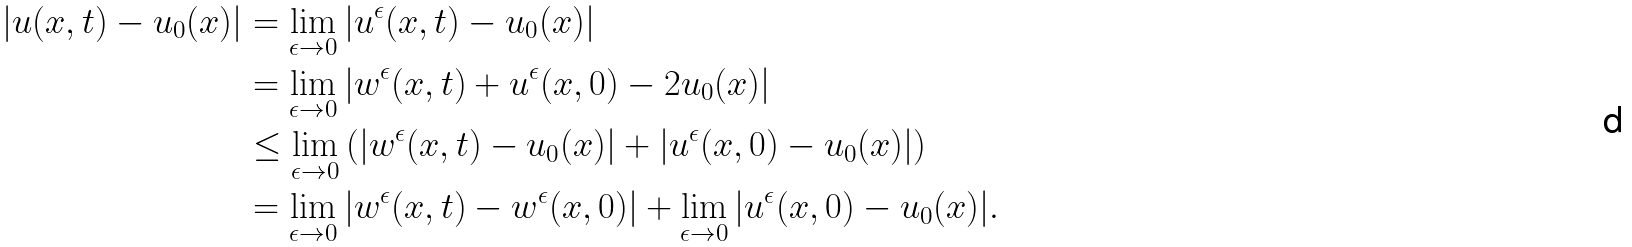Convert formula to latex. <formula><loc_0><loc_0><loc_500><loc_500>| u ( x , t ) - u _ { 0 } ( x ) | & = \lim _ { \epsilon \rightarrow 0 } | u ^ { \epsilon } ( x , t ) - u _ { 0 } ( x ) | \\ & = \lim _ { \epsilon \rightarrow 0 } | w ^ { \epsilon } ( x , t ) + u ^ { \epsilon } ( x , 0 ) - 2 u _ { 0 } ( x ) | \\ & \leq \lim _ { \epsilon \rightarrow 0 } \left ( | w ^ { \epsilon } ( x , t ) - u _ { 0 } ( x ) | + | u ^ { \epsilon } ( x , 0 ) - u _ { 0 } ( x ) | \right ) \\ & = \lim _ { \epsilon \rightarrow 0 } | w ^ { \epsilon } ( x , t ) - w ^ { \epsilon } ( x , 0 ) | + \lim _ { \epsilon \rightarrow 0 } | u ^ { \epsilon } ( x , 0 ) - u _ { 0 } ( x ) | .</formula> 